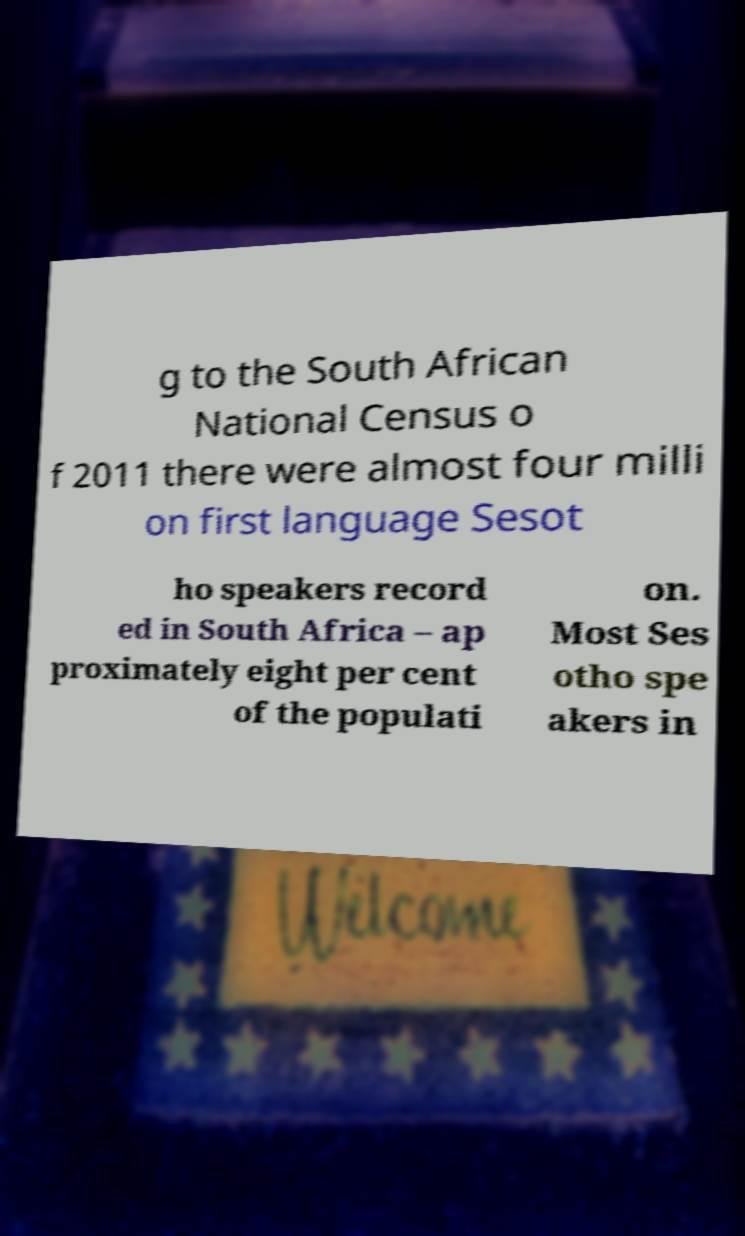Can you accurately transcribe the text from the provided image for me? g to the South African National Census o f 2011 there were almost four milli on first language Sesot ho speakers record ed in South Africa – ap proximately eight per cent of the populati on. Most Ses otho spe akers in 